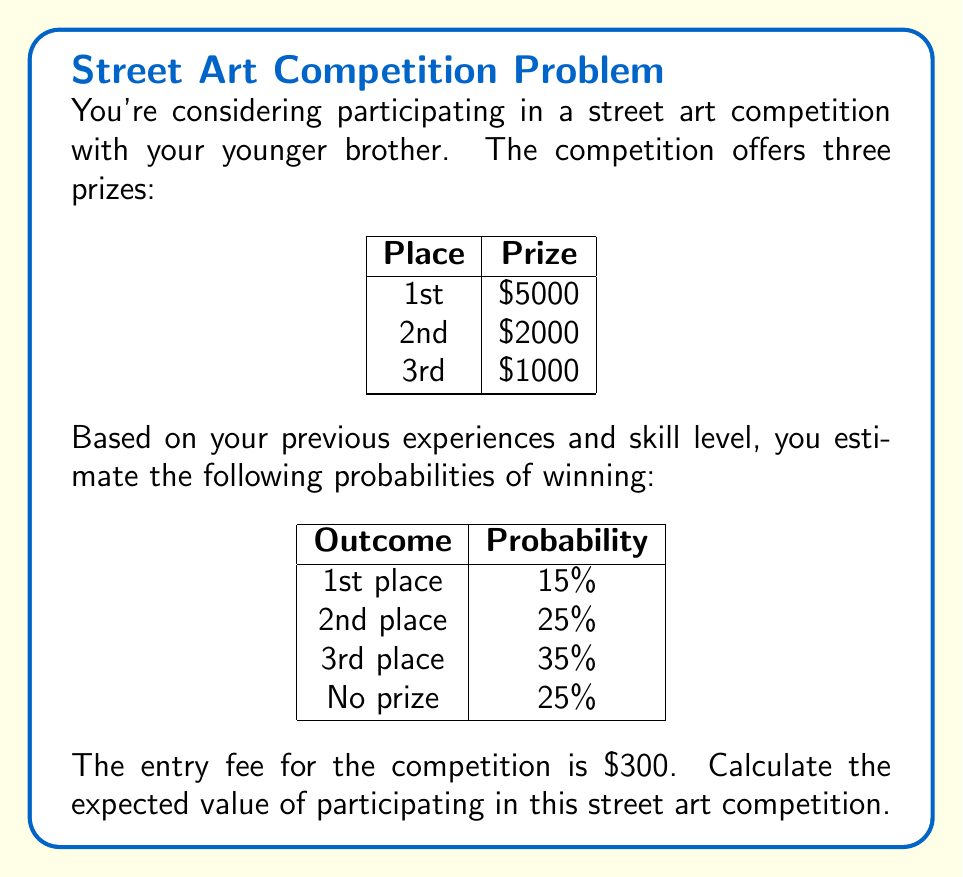What is the answer to this math problem? To calculate the expected value, we need to follow these steps:

1. Calculate the potential gains for each outcome:
   1st place: $5000 - $300 (entry fee) = $4700
   2nd place: $2000 - $300 = $1700
   3rd place: $1000 - $300 = $700
   No prize: -$300 (loss of entry fee)

2. Multiply each potential gain by its probability:
   1st place: $4700 * 0.15 = $705
   2nd place: $1700 * 0.25 = $425
   3rd place: $700 * 0.35 = $245
   No prize: -$300 * 0.25 = -$75

3. Sum up all the values:

   Expected Value = $705 + $425 + $245 + (-$75)
                  = $1300

The formula for expected value is:

$$E(X) = \sum_{i=1}^{n} x_i \cdot p(x_i)$$

Where $x_i$ are the possible outcomes and $p(x_i)$ are their respective probabilities.

In this case:

$$E(X) = 4700 \cdot 0.15 + 1700 \cdot 0.25 + 700 \cdot 0.35 + (-300) \cdot 0.25 = 1300$$
Answer: $1300 